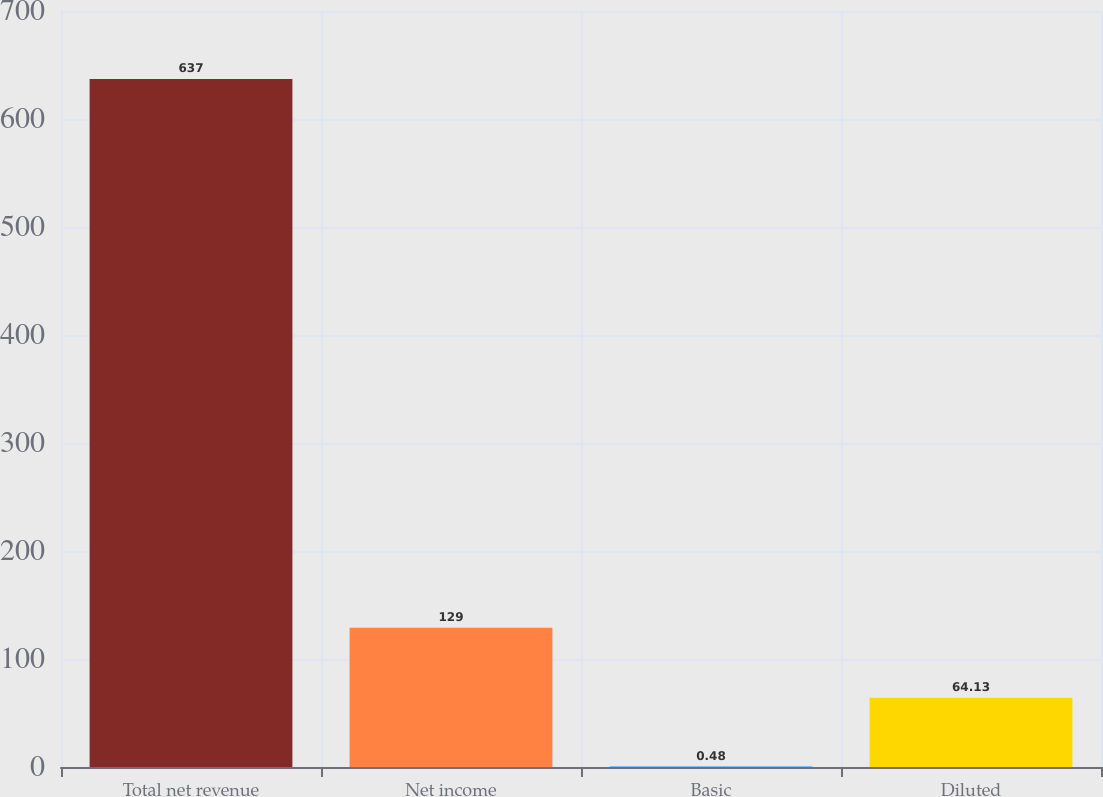Convert chart. <chart><loc_0><loc_0><loc_500><loc_500><bar_chart><fcel>Total net revenue<fcel>Net income<fcel>Basic<fcel>Diluted<nl><fcel>637<fcel>129<fcel>0.48<fcel>64.13<nl></chart> 